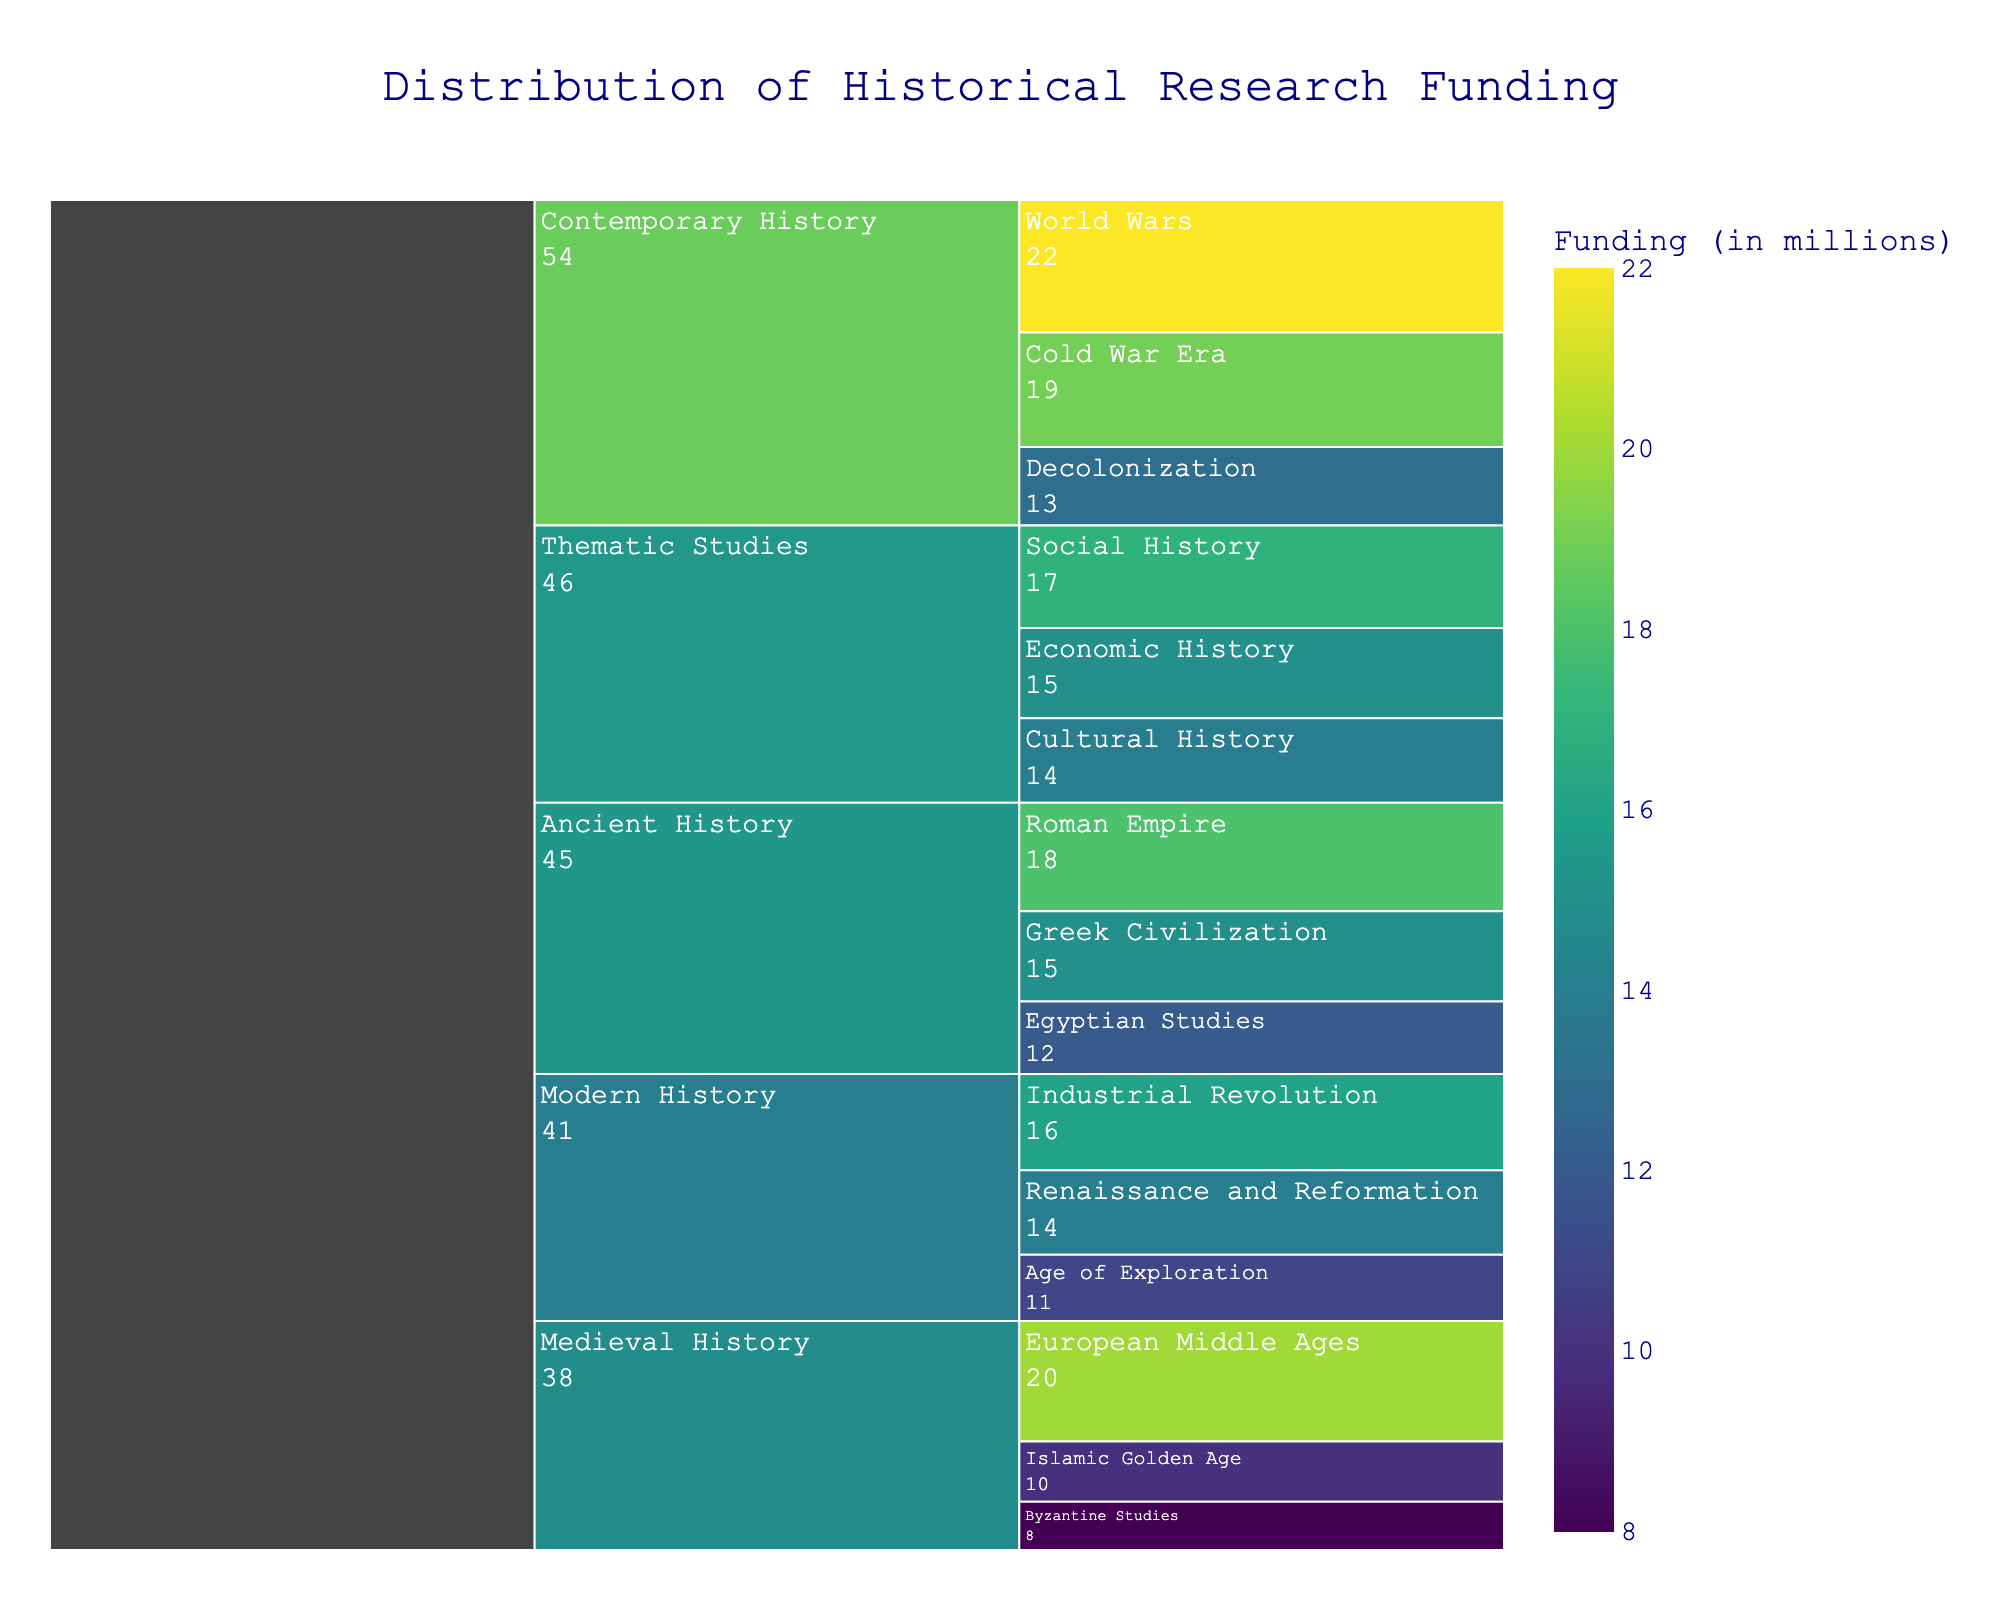What is the total funding for Ancient History? The Icicle chart shows funding distributed across different subcategories within larger categories. To find the total funding for Ancient History, sum the values for Greek Civilization (15M), Roman Empire (18M), and Egyptian Studies (12M): 15M + 18M + 12M = 45M
Answer: 45M Which subcategory within Contemporary History has received the highest funding? The Contemporary History category has three subcategories: World Wars (22M), Cold War Era (19M), and Decolonization (13M). Among these, World Wars has the highest funding at 22M.
Answer: World Wars How does the funding for Thematic Studies compare to Modern History? Thematic Studies has funding distributed across Social History (17M), Economic History (15M), and Cultural History (14M), summing up to 46M. Modern History has funding across Renaissance and Reformation (14M), Age of Exploration (11M), and Industrial Revolution (16M), totaling 41M. Therefore, Thematic Studies has more funding than Modern History: 46M vs 41M.
Answer: Thematic Studies has more funding What is the average funding for the subcategories in Medieval History? The Medieval History category includes European Middle Ages (20M), Byzantine Studies (8M), and Islamic Golden Age (10M). The total funding is 20M + 8M + 10M = 38M. With 3 subcategories, the average funding is 38M / 3 = 12.67M.
Answer: 12.67M Which category has received the least total funding? The chart includes Ancient History (45M), Medieval History (38M), Modern History (41M), Contemporary History (54M), and Thematic Studies (46M). Among these, Medieval History has the least total funding at 38M.
Answer: Medieval History Is there any subcategory that has funding equal to the mean funding of all subcategories combined? First, calculate the total funding for all subcategories: 15M + 18M + 12M + 20M + 8M + 10M + 14M + 11M + 16M + 22M + 19M + 13M + 17M + 15M + 14M = 224M. There are 15 subcategories, so the mean funding is 224M / 15 = 14.93M. Checking the Icicle chart, no subcategory has funding exactly equal to 14.93M.
Answer: No What is the combined funding for subcategories related to war topics? The two war-related subcategories are World Wars (22M) and Cold War Era (19M). Their combined funding is 22M + 19M = 41M.
Answer: 41M Which subcategory in Thematic Studies has the lowest funding? Within Thematic Studies, the subcategories are Social History (17M), Economic History (15M), and Cultural History (14M). Cultural History has the lowest funding at 14M.
Answer: Cultural History 